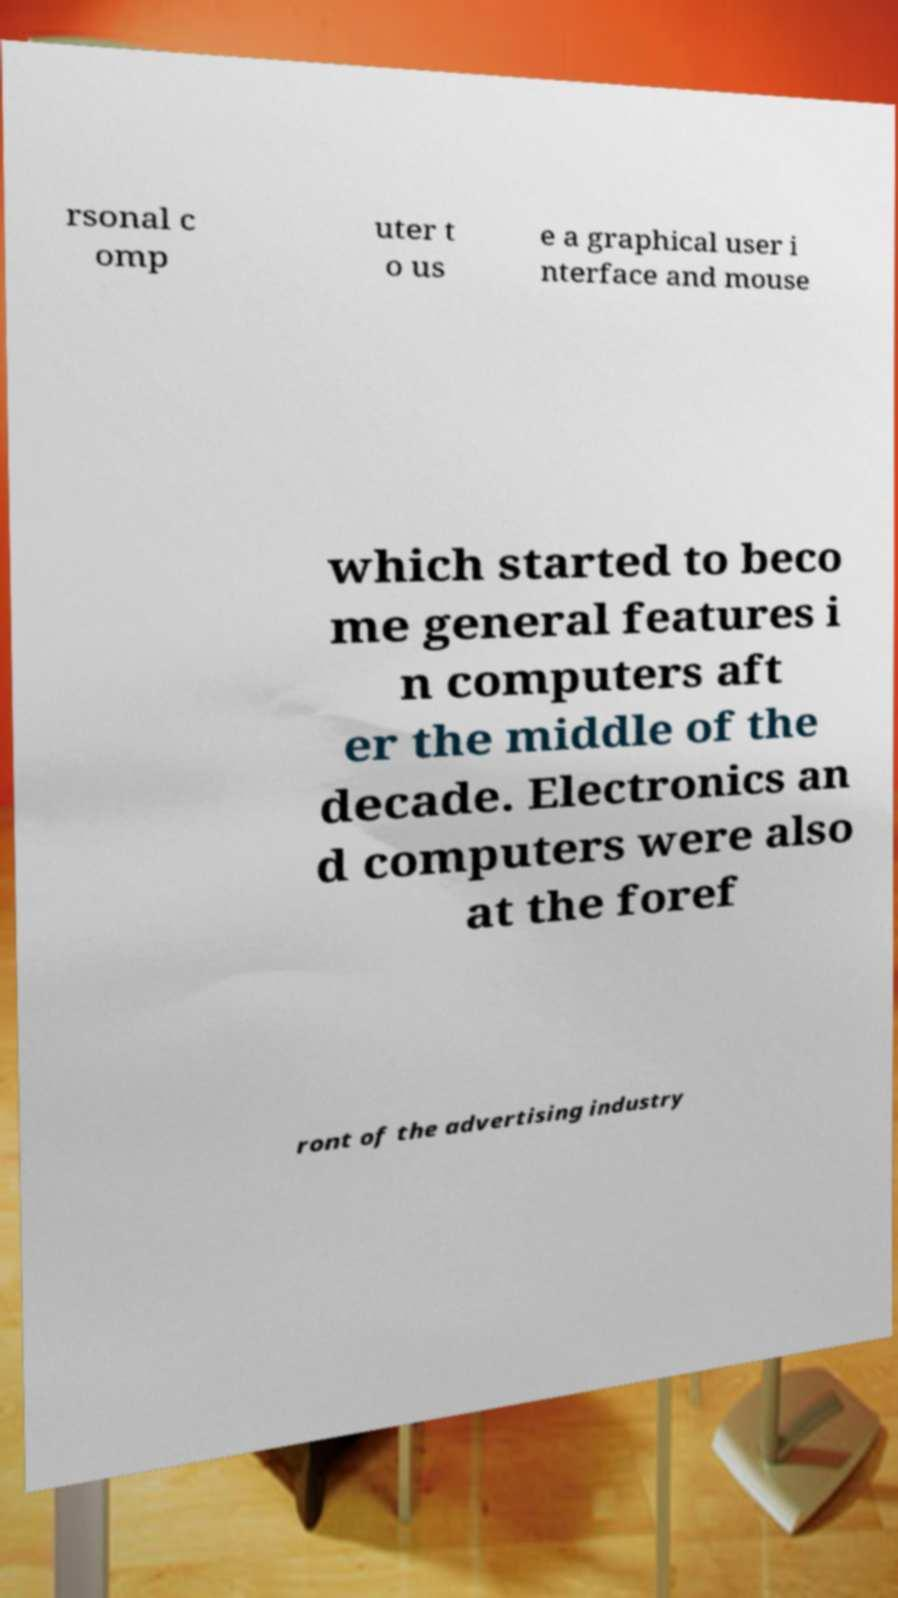Can you read and provide the text displayed in the image?This photo seems to have some interesting text. Can you extract and type it out for me? rsonal c omp uter t o us e a graphical user i nterface and mouse which started to beco me general features i n computers aft er the middle of the decade. Electronics an d computers were also at the foref ront of the advertising industry 